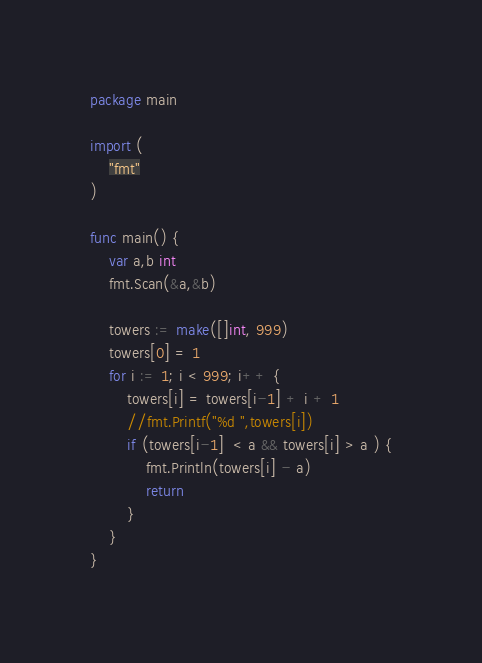<code> <loc_0><loc_0><loc_500><loc_500><_Go_>package main

import (
	"fmt"
)

func main() {
	var a,b int
	fmt.Scan(&a,&b)
	
	towers := make([]int, 999)
	towers[0] = 1
	for i := 1; i < 999; i++ {
		towers[i] = towers[i-1] + i + 1
     	//fmt.Printf("%d ",towers[i])
		if (towers[i-1]  < a && towers[i] > a ) {
			fmt.Println(towers[i] - a)
			return
		}
	}
}</code> 